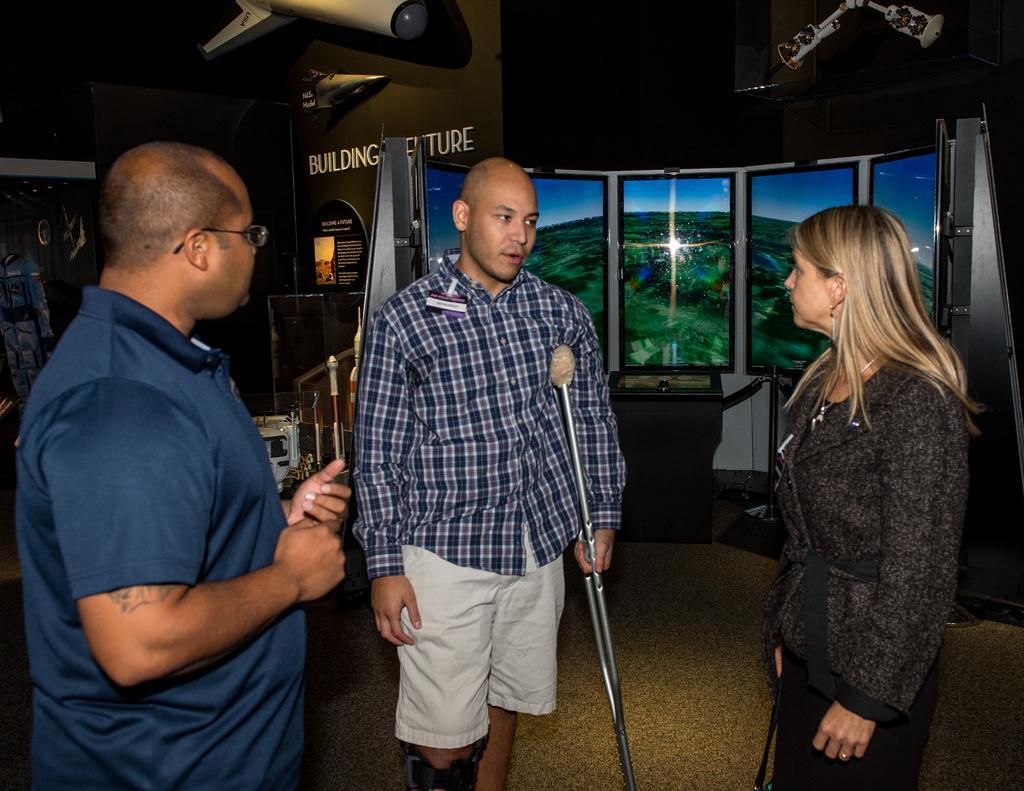How would you summarize this image in a sentence or two? In this picture we can see two men and a woman standing on the floor and in the background we can see windows and some objects. 